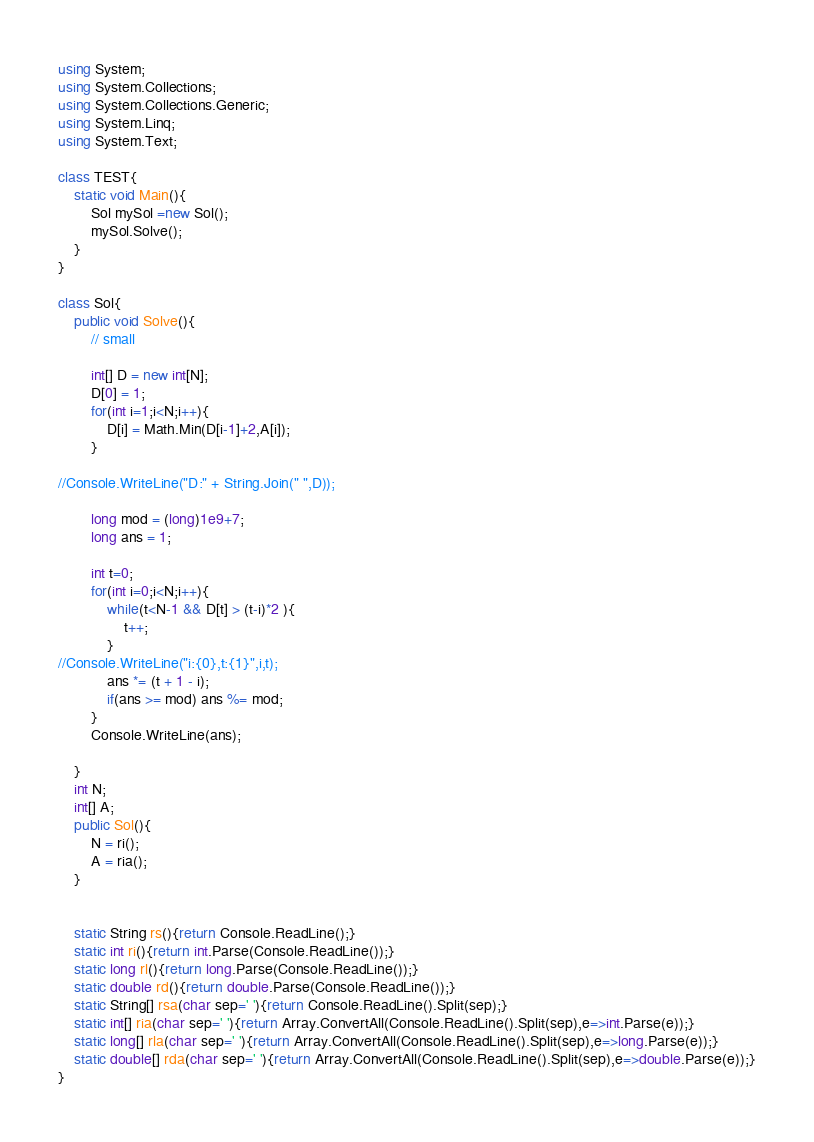Convert code to text. <code><loc_0><loc_0><loc_500><loc_500><_C#_>using System;
using System.Collections;
using System.Collections.Generic;
using System.Linq;
using System.Text;

class TEST{
	static void Main(){
		Sol mySol =new Sol();
		mySol.Solve();
	}
}

class Sol{
	public void Solve(){
		// small
		
		int[] D = new int[N];
		D[0] = 1;
		for(int i=1;i<N;i++){
			D[i] = Math.Min(D[i-1]+2,A[i]);
		}
		
//Console.WriteLine("D:" + String.Join(" ",D));
		
		long mod = (long)1e9+7;
		long ans = 1;
		
		int t=0;
		for(int i=0;i<N;i++){
			while(t<N-1 && D[t] > (t-i)*2 ){
				t++;
			}
//Console.WriteLine("i:{0},t:{1}",i,t);
			ans *= (t + 1 - i);
			if(ans >= mod) ans %= mod;
		}
		Console.WriteLine(ans);
		
	}
	int N;
	int[] A;
	public Sol(){
		N = ri();
		A = ria();
	}
	

	static String rs(){return Console.ReadLine();}
	static int ri(){return int.Parse(Console.ReadLine());}
	static long rl(){return long.Parse(Console.ReadLine());}
	static double rd(){return double.Parse(Console.ReadLine());}
	static String[] rsa(char sep=' '){return Console.ReadLine().Split(sep);}
	static int[] ria(char sep=' '){return Array.ConvertAll(Console.ReadLine().Split(sep),e=>int.Parse(e));}
	static long[] rla(char sep=' '){return Array.ConvertAll(Console.ReadLine().Split(sep),e=>long.Parse(e));}
	static double[] rda(char sep=' '){return Array.ConvertAll(Console.ReadLine().Split(sep),e=>double.Parse(e));}
}
</code> 